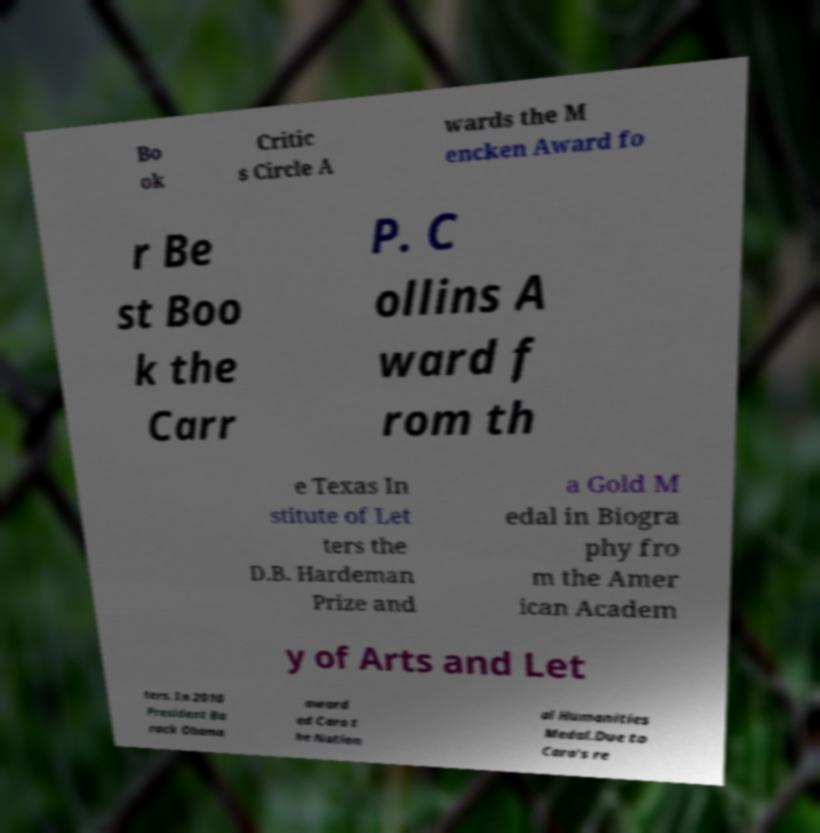What messages or text are displayed in this image? I need them in a readable, typed format. Bo ok Critic s Circle A wards the M encken Award fo r Be st Boo k the Carr P. C ollins A ward f rom th e Texas In stitute of Let ters the D.B. Hardeman Prize and a Gold M edal in Biogra phy fro m the Amer ican Academ y of Arts and Let ters. In 2010 President Ba rack Obama award ed Caro t he Nation al Humanities Medal.Due to Caro's re 